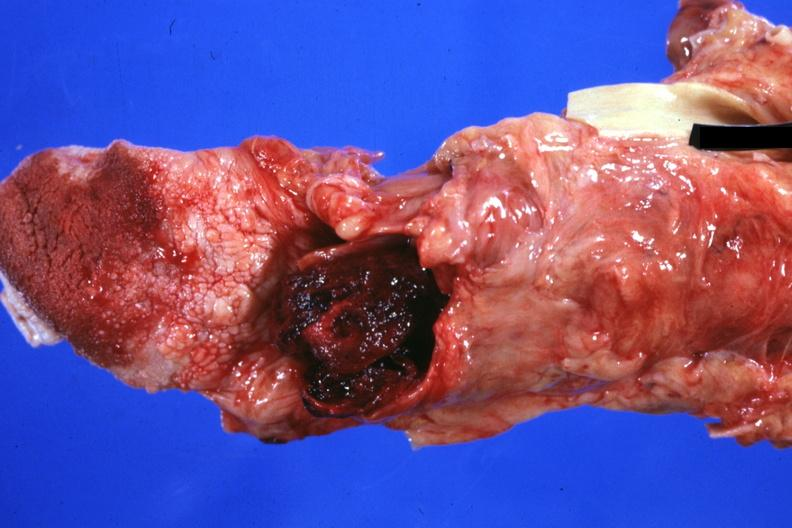s oral present?
Answer the question using a single word or phrase. Yes 